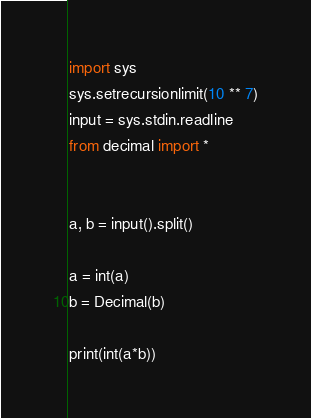<code> <loc_0><loc_0><loc_500><loc_500><_Python_>import sys
sys.setrecursionlimit(10 ** 7)
input = sys.stdin.readline
from decimal import *


a, b = input().split()

a = int(a)
b = Decimal(b)

print(int(a*b))

</code> 